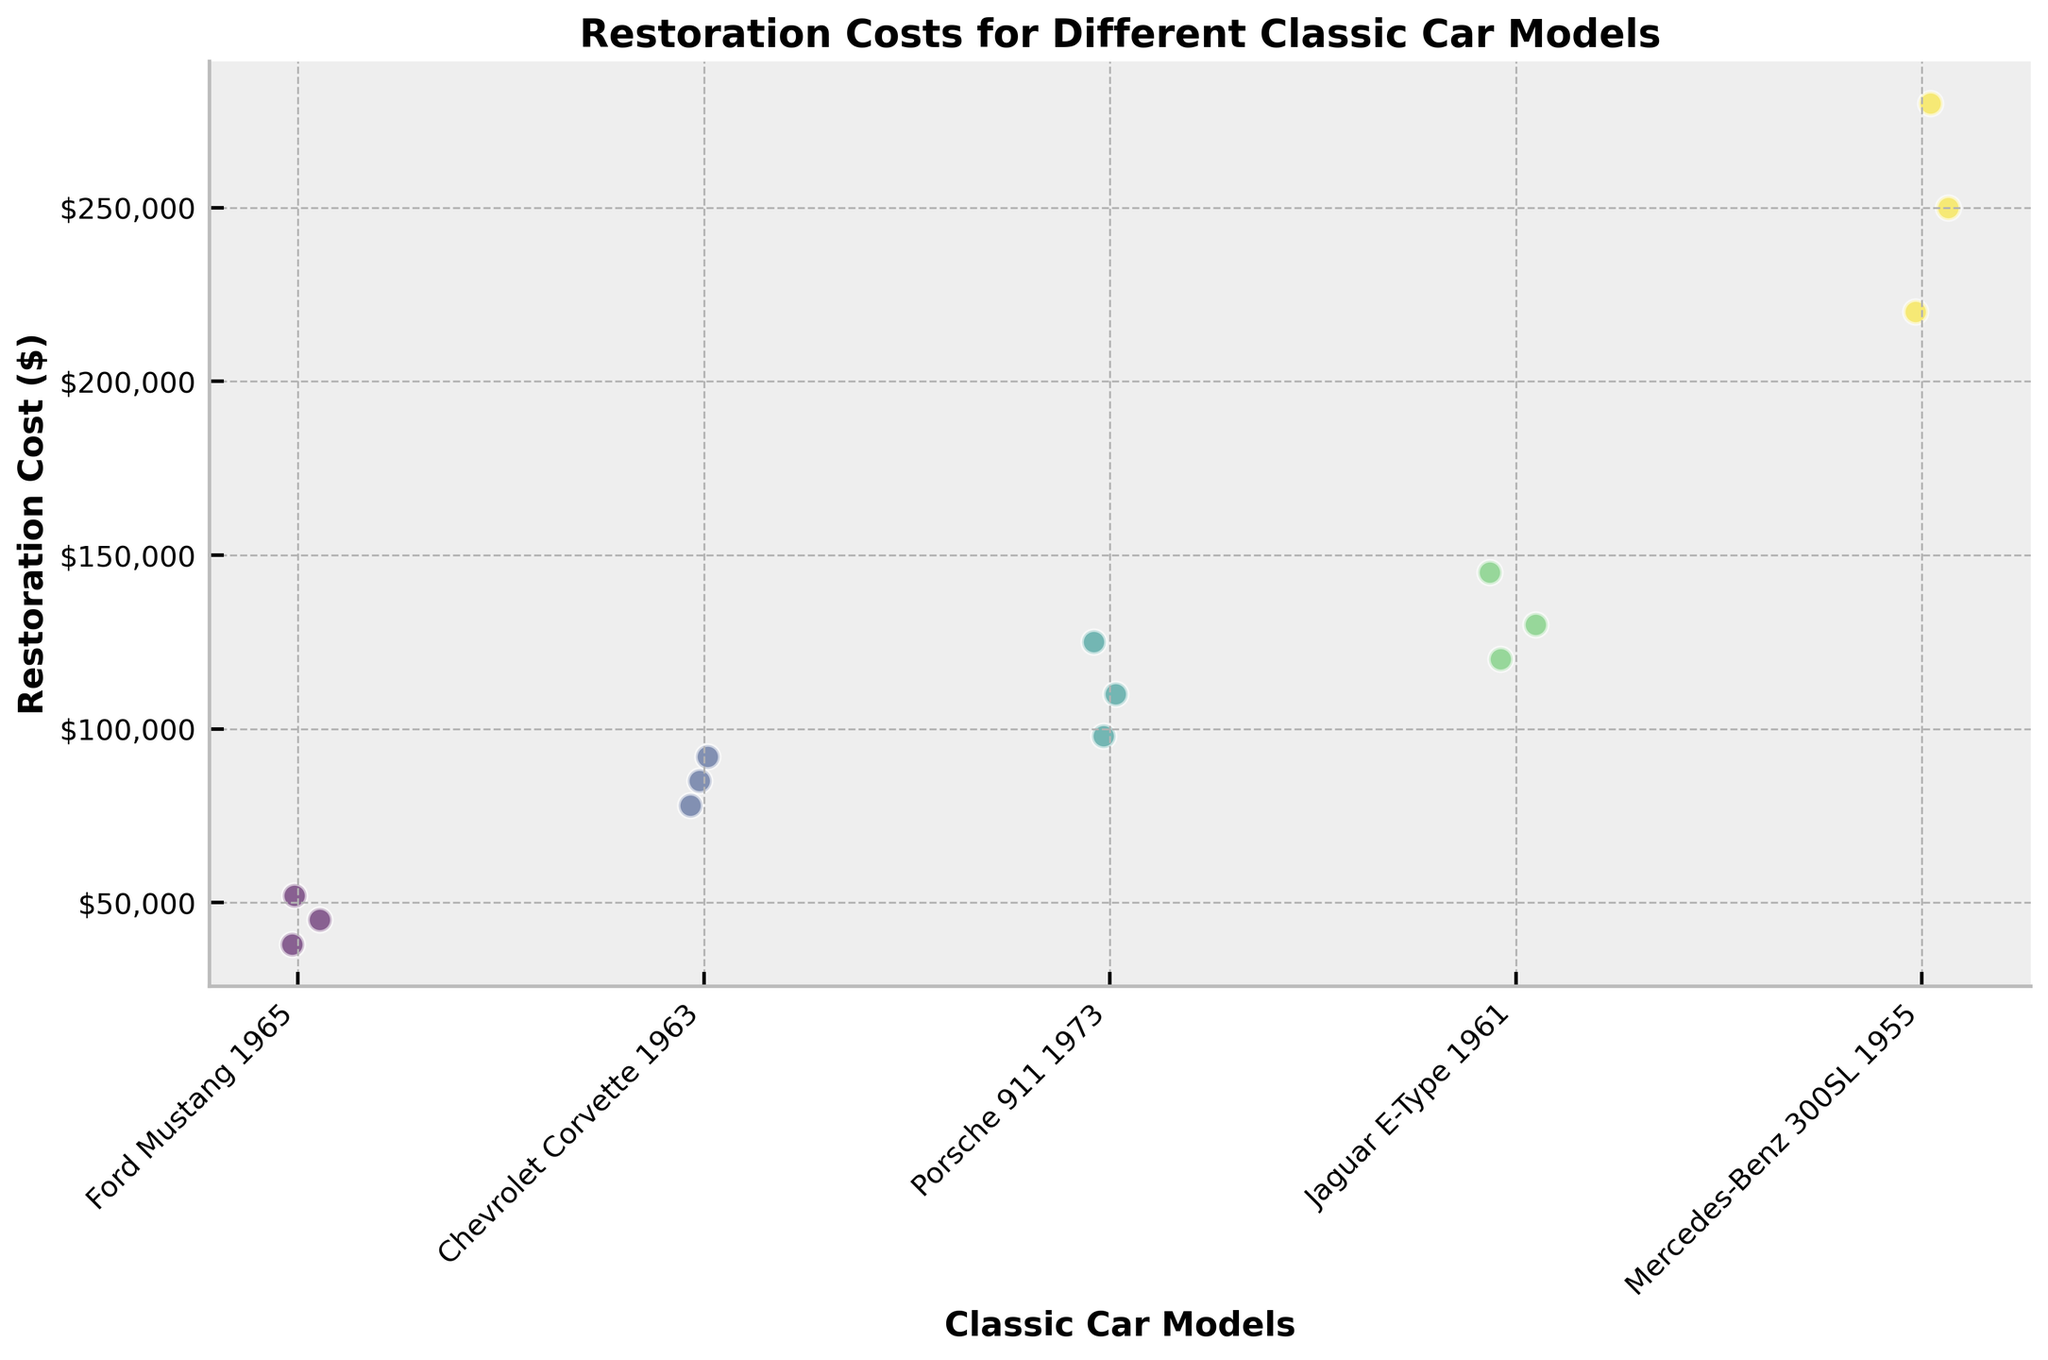What's the title of the figure? The title of the figure is displayed at the top of the figure.
Answer: Restoration Costs for Different Classic Car Models What does the x-axis represent? The x-axis represents different classic car models.
Answer: Classic Car Models Which car model has the highest restoration cost in the figure? By observing the highest point on the y-axis for each model, the Jaguar E-Type 1961 has the highest restoration cost.
Answer: Jaguar E-Type 1961 How many Ford Mustang 1965 data points are shown? By counting the number of dots corresponding to the Ford Mustang 1965 model, there are three data points visible.
Answer: 3 What’s the label of the y-axis? The label of the y-axis is shown to the left of the axis.
Answer: Restoration Cost ($) Which car models have restoration costs that exceed $200,000? Observe the models on the x-axis and the corresponding y-axis values to see which models have points above $200,000. The Mercedes-Benz 300SL 1955 has restoration costs that exceed $200,000.
Answer: Mercedes-Benz 300SL 1955 What's the average restoration cost for the Chevrolet Corvette 1963? To find the average, sum the restoration costs for the Chevrolet Corvette 1963 (85000, 92000, 78000) and divide by the number of data points (3). The calculation is (85000 + 92000 + 78000) / 3 = 85000.
Answer: 85,000 Is the variation in restoration costs larger for the Porsche 911 1973 or the Ford Mustang 1965? Compare the range of restoration costs (highest value - lowest value) for both models: Porsche 911 1973 (125,000 – 98,000 = 27,000) and Ford Mustang 1965 (52,000 – 38,000 = 14,000). The Porsche 911 1973 has a larger variation.
Answer: Porsche 911 1973 Which car model shows the smallest range of restoration costs? Calculate the range for each model and compare: Ford Mustang 1965 (52,000 – 38,000 = 14,000), Chevrolet Corvette 1963 (92,000 – 78,000 = 14,000), Porsche 911 1973 (125,000 – 98,000 = 27,000), Jaguar E-Type 1961 (145,000 – 120,000 = 25,000), Mercedes-Benz 300SL 1955 (280,000 – 220,000 = 60,000). Both Ford Mustang 1965 and Chevrolet Corvette 1963 have the smallest range of 14,000.
Answer: Ford Mustang 1965 and Chevrolet Corvette 1963 